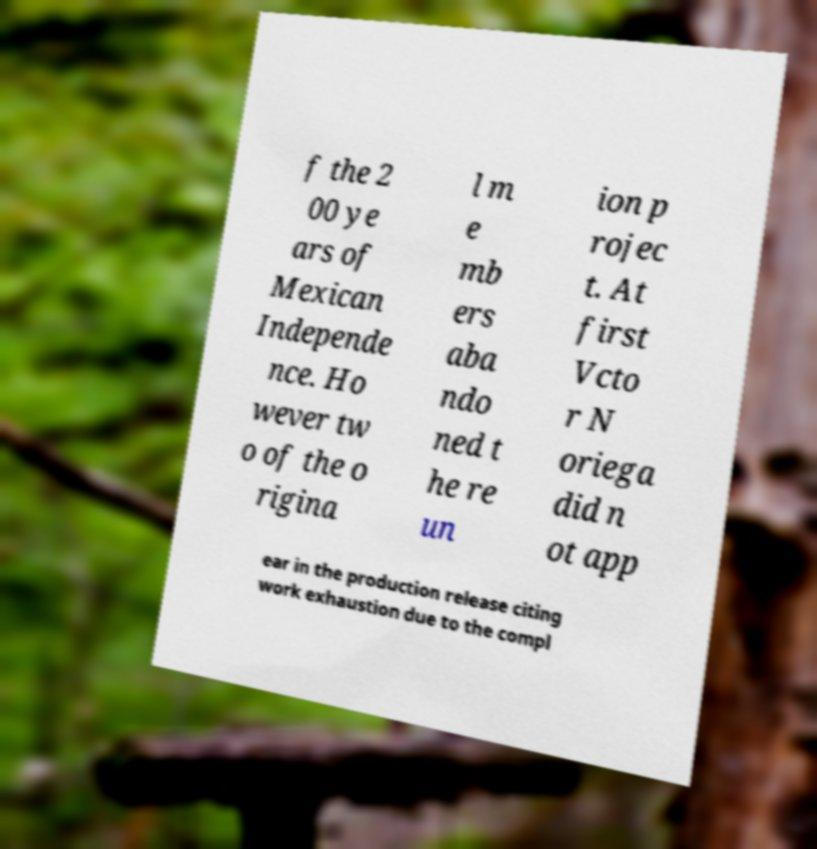Can you accurately transcribe the text from the provided image for me? f the 2 00 ye ars of Mexican Independe nce. Ho wever tw o of the o rigina l m e mb ers aba ndo ned t he re un ion p rojec t. At first Vcto r N oriega did n ot app ear in the production release citing work exhaustion due to the compl 